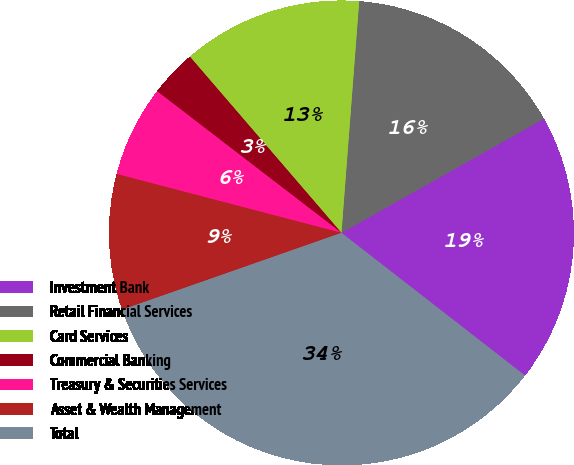Convert chart to OTSL. <chart><loc_0><loc_0><loc_500><loc_500><pie_chart><fcel>Investment Bank<fcel>Retail Financial Services<fcel>Card Services<fcel>Commercial Banking<fcel>Treasury & Securities Services<fcel>Asset & Wealth Management<fcel>Total<nl><fcel>18.69%<fcel>15.61%<fcel>12.52%<fcel>3.27%<fcel>6.35%<fcel>9.44%<fcel>34.12%<nl></chart> 